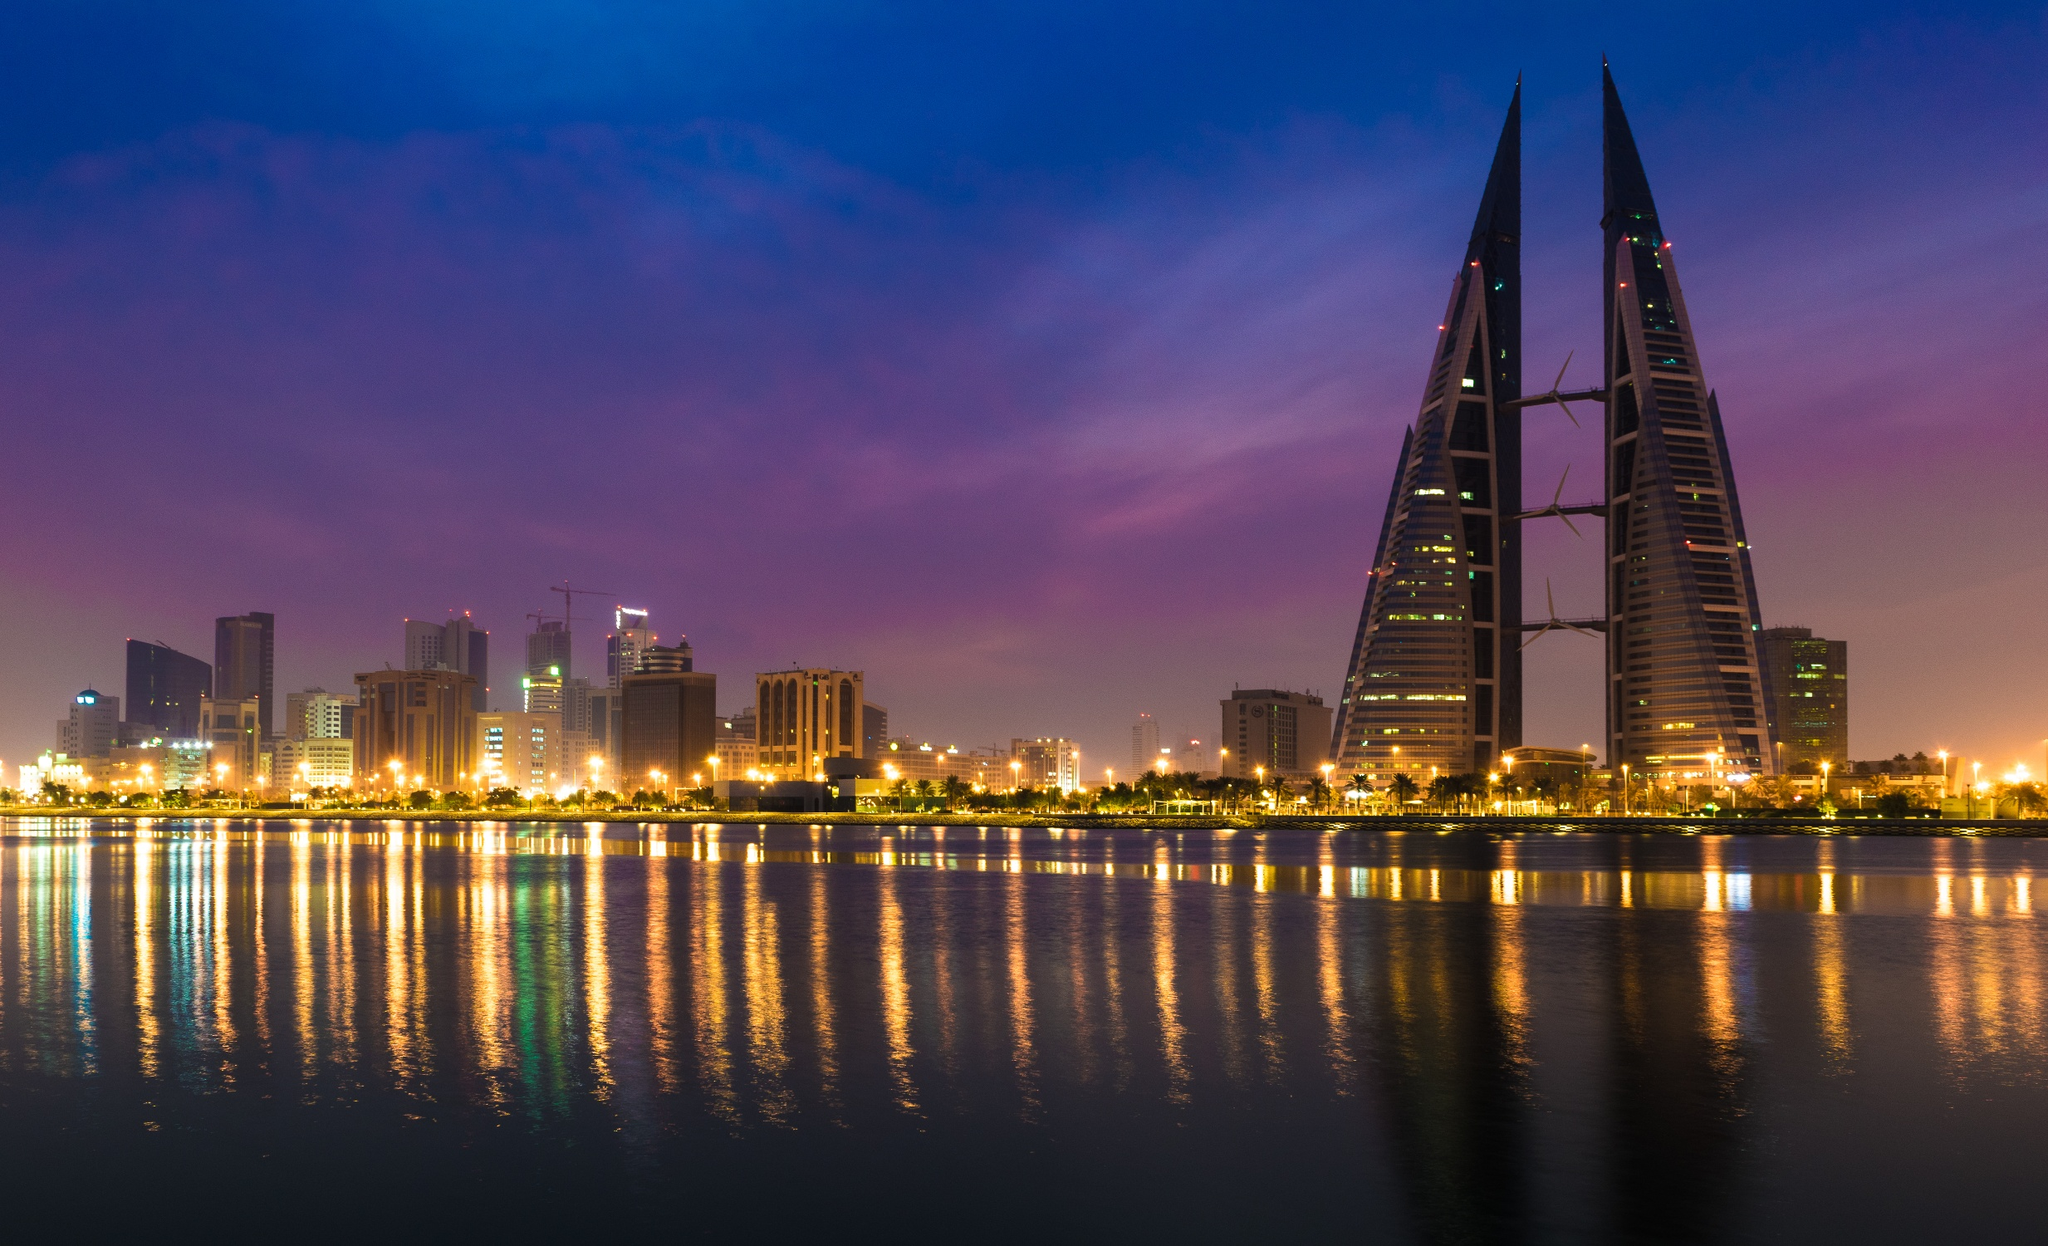What architectural features are distinctive in this scene? The Bahrain World Trade Center stands out with its two sail-shaped towers, a unique design that integrates three large wind turbines between them, emphasizing sustainability and innovation. What makes this building an icon of sustainable architecture? The Bahrain World Trade Center is renowned for its integration of wind turbines within the structure, making it one of the first skyscrapers to incorporate such sustainable technology on a large scale. These turbines harness the wind to generate energy for the building, significantly reducing its carbon footprint and operational costs. This innovative approach not only highlights the architectural ingenuity but also promotes environmentally friendly practices in urban construction. Imagine standing on the waterfront at the very moment this photo was taken. Describe the atmosphere. Standing on the waterfront, you would feel a gentle evening breeze as the sky transitions from a soft pink to a deeper purple. The city's lights flicker and reflect on the perfectly still water, creating a mesmerizing kaleidoscope of colors. The tranquil ambiance is punctuated by the hum of distant city life, while the towering Bahrain World Trade Center commands attention with its striking illumination. The overall experience is serene and awe-inspiring, a moment that amplifies the fusion of natural beauty and modern architecture. 